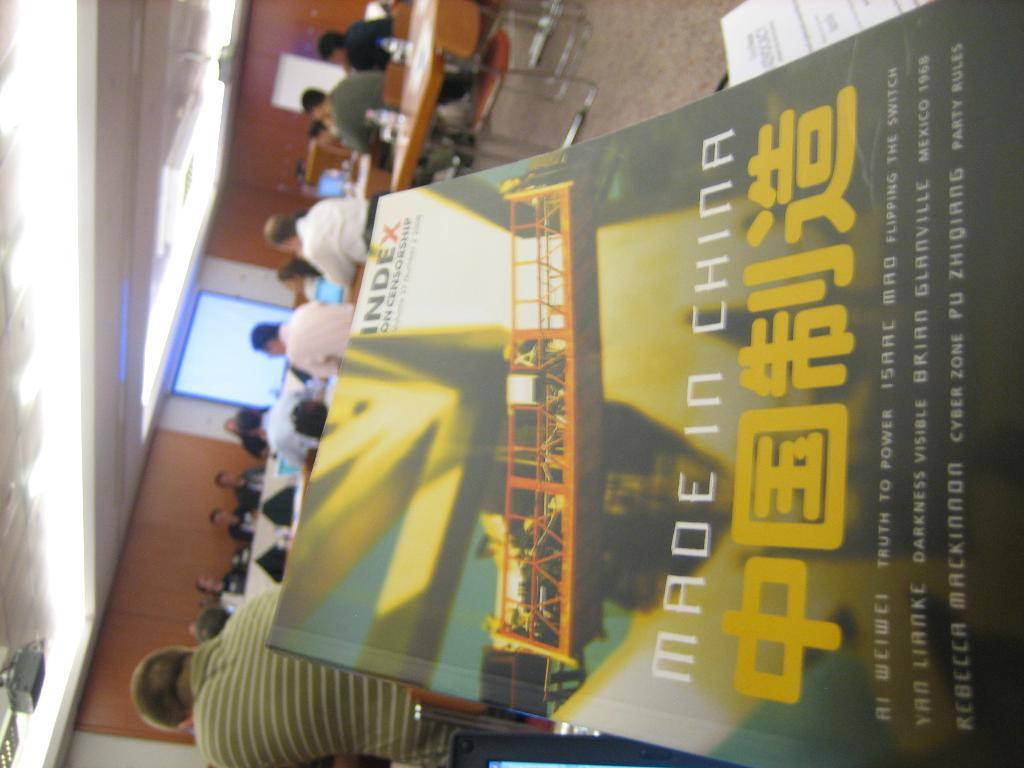Provide a one-sentence caption for the provided image. A book that says made in china with people sitting at desks in the background. 